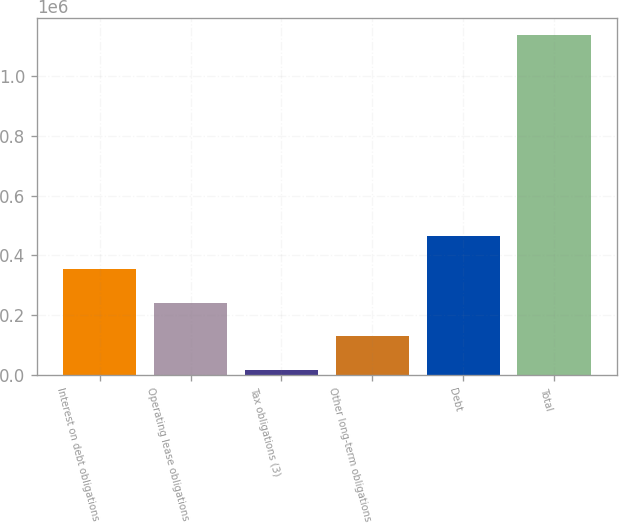Convert chart. <chart><loc_0><loc_0><loc_500><loc_500><bar_chart><fcel>Interest on debt obligations<fcel>Operating lease obligations<fcel>Tax obligations (3)<fcel>Other long-term obligations<fcel>Debt<fcel>Total<nl><fcel>353538<fcel>241371<fcel>17038<fcel>129204<fcel>465704<fcel>1.1387e+06<nl></chart> 